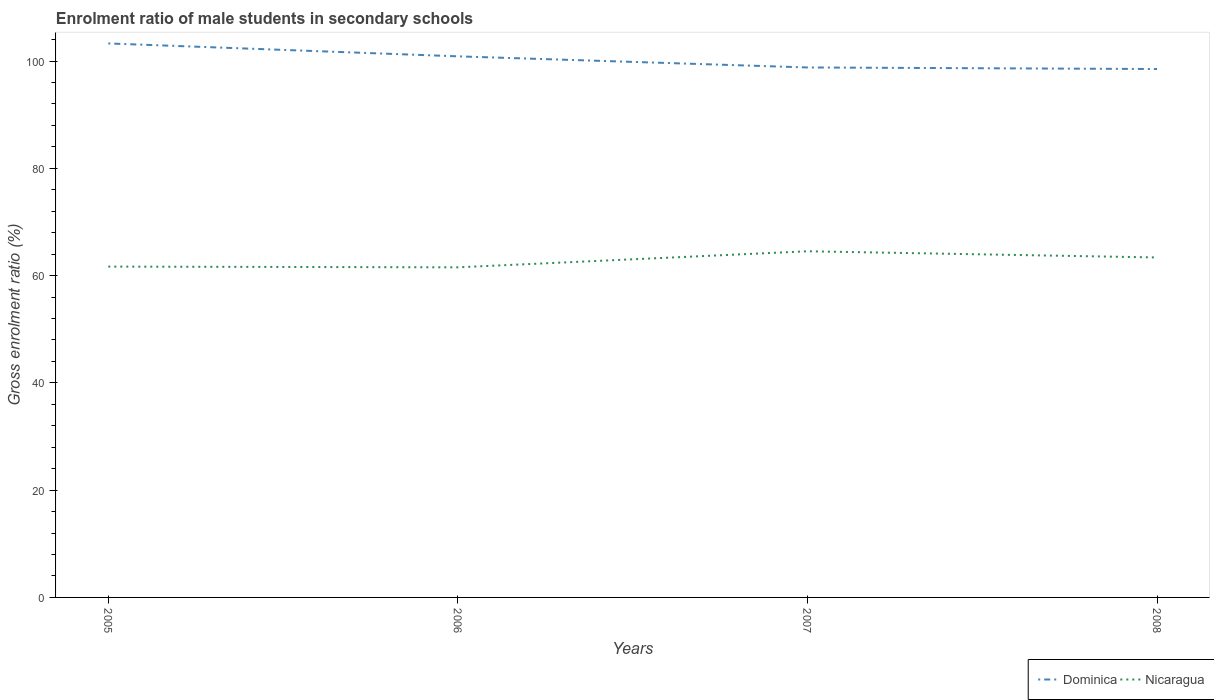Across all years, what is the maximum enrolment ratio of male students in secondary schools in Dominica?
Your response must be concise. 98.52. In which year was the enrolment ratio of male students in secondary schools in Nicaragua maximum?
Your response must be concise. 2006. What is the total enrolment ratio of male students in secondary schools in Nicaragua in the graph?
Give a very brief answer. 0.14. What is the difference between the highest and the second highest enrolment ratio of male students in secondary schools in Dominica?
Offer a very short reply. 4.77. Is the enrolment ratio of male students in secondary schools in Nicaragua strictly greater than the enrolment ratio of male students in secondary schools in Dominica over the years?
Make the answer very short. Yes. How many years are there in the graph?
Your answer should be very brief. 4. What is the difference between two consecutive major ticks on the Y-axis?
Keep it short and to the point. 20. Are the values on the major ticks of Y-axis written in scientific E-notation?
Keep it short and to the point. No. Does the graph contain any zero values?
Your answer should be compact. No. Does the graph contain grids?
Ensure brevity in your answer.  No. Where does the legend appear in the graph?
Ensure brevity in your answer.  Bottom right. How are the legend labels stacked?
Your response must be concise. Horizontal. What is the title of the graph?
Ensure brevity in your answer.  Enrolment ratio of male students in secondary schools. Does "Bermuda" appear as one of the legend labels in the graph?
Ensure brevity in your answer.  No. What is the label or title of the X-axis?
Your response must be concise. Years. What is the label or title of the Y-axis?
Your answer should be compact. Gross enrolment ratio (%). What is the Gross enrolment ratio (%) in Dominica in 2005?
Offer a very short reply. 103.29. What is the Gross enrolment ratio (%) in Nicaragua in 2005?
Offer a very short reply. 61.68. What is the Gross enrolment ratio (%) in Dominica in 2006?
Give a very brief answer. 100.88. What is the Gross enrolment ratio (%) in Nicaragua in 2006?
Give a very brief answer. 61.55. What is the Gross enrolment ratio (%) of Dominica in 2007?
Provide a short and direct response. 98.81. What is the Gross enrolment ratio (%) in Nicaragua in 2007?
Offer a terse response. 64.54. What is the Gross enrolment ratio (%) of Dominica in 2008?
Provide a succinct answer. 98.52. What is the Gross enrolment ratio (%) of Nicaragua in 2008?
Offer a very short reply. 63.39. Across all years, what is the maximum Gross enrolment ratio (%) of Dominica?
Provide a short and direct response. 103.29. Across all years, what is the maximum Gross enrolment ratio (%) of Nicaragua?
Provide a short and direct response. 64.54. Across all years, what is the minimum Gross enrolment ratio (%) in Dominica?
Your answer should be compact. 98.52. Across all years, what is the minimum Gross enrolment ratio (%) in Nicaragua?
Your answer should be compact. 61.55. What is the total Gross enrolment ratio (%) of Dominica in the graph?
Ensure brevity in your answer.  401.5. What is the total Gross enrolment ratio (%) in Nicaragua in the graph?
Make the answer very short. 251.16. What is the difference between the Gross enrolment ratio (%) of Dominica in 2005 and that in 2006?
Provide a short and direct response. 2.4. What is the difference between the Gross enrolment ratio (%) of Nicaragua in 2005 and that in 2006?
Make the answer very short. 0.14. What is the difference between the Gross enrolment ratio (%) of Dominica in 2005 and that in 2007?
Provide a succinct answer. 4.48. What is the difference between the Gross enrolment ratio (%) in Nicaragua in 2005 and that in 2007?
Your answer should be very brief. -2.86. What is the difference between the Gross enrolment ratio (%) of Dominica in 2005 and that in 2008?
Provide a short and direct response. 4.77. What is the difference between the Gross enrolment ratio (%) in Nicaragua in 2005 and that in 2008?
Your answer should be very brief. -1.7. What is the difference between the Gross enrolment ratio (%) in Dominica in 2006 and that in 2007?
Keep it short and to the point. 2.07. What is the difference between the Gross enrolment ratio (%) of Nicaragua in 2006 and that in 2007?
Offer a terse response. -3. What is the difference between the Gross enrolment ratio (%) in Dominica in 2006 and that in 2008?
Give a very brief answer. 2.37. What is the difference between the Gross enrolment ratio (%) in Nicaragua in 2006 and that in 2008?
Provide a succinct answer. -1.84. What is the difference between the Gross enrolment ratio (%) of Dominica in 2007 and that in 2008?
Make the answer very short. 0.29. What is the difference between the Gross enrolment ratio (%) in Nicaragua in 2007 and that in 2008?
Your response must be concise. 1.16. What is the difference between the Gross enrolment ratio (%) in Dominica in 2005 and the Gross enrolment ratio (%) in Nicaragua in 2006?
Offer a terse response. 41.74. What is the difference between the Gross enrolment ratio (%) in Dominica in 2005 and the Gross enrolment ratio (%) in Nicaragua in 2007?
Ensure brevity in your answer.  38.75. What is the difference between the Gross enrolment ratio (%) of Dominica in 2005 and the Gross enrolment ratio (%) of Nicaragua in 2008?
Provide a short and direct response. 39.9. What is the difference between the Gross enrolment ratio (%) in Dominica in 2006 and the Gross enrolment ratio (%) in Nicaragua in 2007?
Offer a very short reply. 36.34. What is the difference between the Gross enrolment ratio (%) of Dominica in 2006 and the Gross enrolment ratio (%) of Nicaragua in 2008?
Offer a terse response. 37.5. What is the difference between the Gross enrolment ratio (%) in Dominica in 2007 and the Gross enrolment ratio (%) in Nicaragua in 2008?
Keep it short and to the point. 35.43. What is the average Gross enrolment ratio (%) of Dominica per year?
Keep it short and to the point. 100.38. What is the average Gross enrolment ratio (%) in Nicaragua per year?
Give a very brief answer. 62.79. In the year 2005, what is the difference between the Gross enrolment ratio (%) of Dominica and Gross enrolment ratio (%) of Nicaragua?
Your answer should be compact. 41.61. In the year 2006, what is the difference between the Gross enrolment ratio (%) in Dominica and Gross enrolment ratio (%) in Nicaragua?
Provide a succinct answer. 39.34. In the year 2007, what is the difference between the Gross enrolment ratio (%) of Dominica and Gross enrolment ratio (%) of Nicaragua?
Keep it short and to the point. 34.27. In the year 2008, what is the difference between the Gross enrolment ratio (%) of Dominica and Gross enrolment ratio (%) of Nicaragua?
Your response must be concise. 35.13. What is the ratio of the Gross enrolment ratio (%) in Dominica in 2005 to that in 2006?
Your answer should be compact. 1.02. What is the ratio of the Gross enrolment ratio (%) in Dominica in 2005 to that in 2007?
Your answer should be compact. 1.05. What is the ratio of the Gross enrolment ratio (%) in Nicaragua in 2005 to that in 2007?
Provide a short and direct response. 0.96. What is the ratio of the Gross enrolment ratio (%) of Dominica in 2005 to that in 2008?
Your answer should be compact. 1.05. What is the ratio of the Gross enrolment ratio (%) of Nicaragua in 2005 to that in 2008?
Make the answer very short. 0.97. What is the ratio of the Gross enrolment ratio (%) of Nicaragua in 2006 to that in 2007?
Keep it short and to the point. 0.95. What is the ratio of the Gross enrolment ratio (%) in Dominica in 2006 to that in 2008?
Your answer should be very brief. 1.02. What is the ratio of the Gross enrolment ratio (%) of Nicaragua in 2006 to that in 2008?
Your response must be concise. 0.97. What is the ratio of the Gross enrolment ratio (%) in Nicaragua in 2007 to that in 2008?
Make the answer very short. 1.02. What is the difference between the highest and the second highest Gross enrolment ratio (%) in Dominica?
Give a very brief answer. 2.4. What is the difference between the highest and the second highest Gross enrolment ratio (%) in Nicaragua?
Give a very brief answer. 1.16. What is the difference between the highest and the lowest Gross enrolment ratio (%) of Dominica?
Ensure brevity in your answer.  4.77. What is the difference between the highest and the lowest Gross enrolment ratio (%) in Nicaragua?
Your response must be concise. 3. 